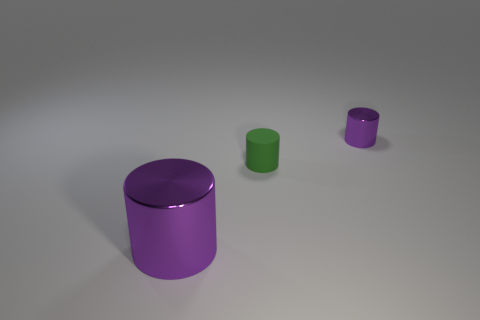Are the purple object that is behind the small matte object and the large purple object made of the same material?
Make the answer very short. Yes. What is the shape of the small metallic thing?
Give a very brief answer. Cylinder. There is a metal cylinder that is in front of the purple metallic cylinder that is on the right side of the large cylinder; what number of tiny green matte cylinders are on the right side of it?
Offer a very short reply. 1. How many other objects are there of the same material as the tiny purple thing?
Provide a succinct answer. 1. What material is the purple cylinder that is the same size as the green cylinder?
Your response must be concise. Metal. There is a metal cylinder right of the big purple metal object; is it the same color as the thing left of the green cylinder?
Your answer should be compact. Yes. Is there a purple metallic thing of the same shape as the matte object?
Provide a succinct answer. Yes. What shape is the purple thing that is the same size as the green rubber object?
Your answer should be compact. Cylinder. What number of tiny matte cylinders have the same color as the large metal thing?
Provide a succinct answer. 0. What size is the metallic object that is in front of the tiny green matte object?
Ensure brevity in your answer.  Large. 